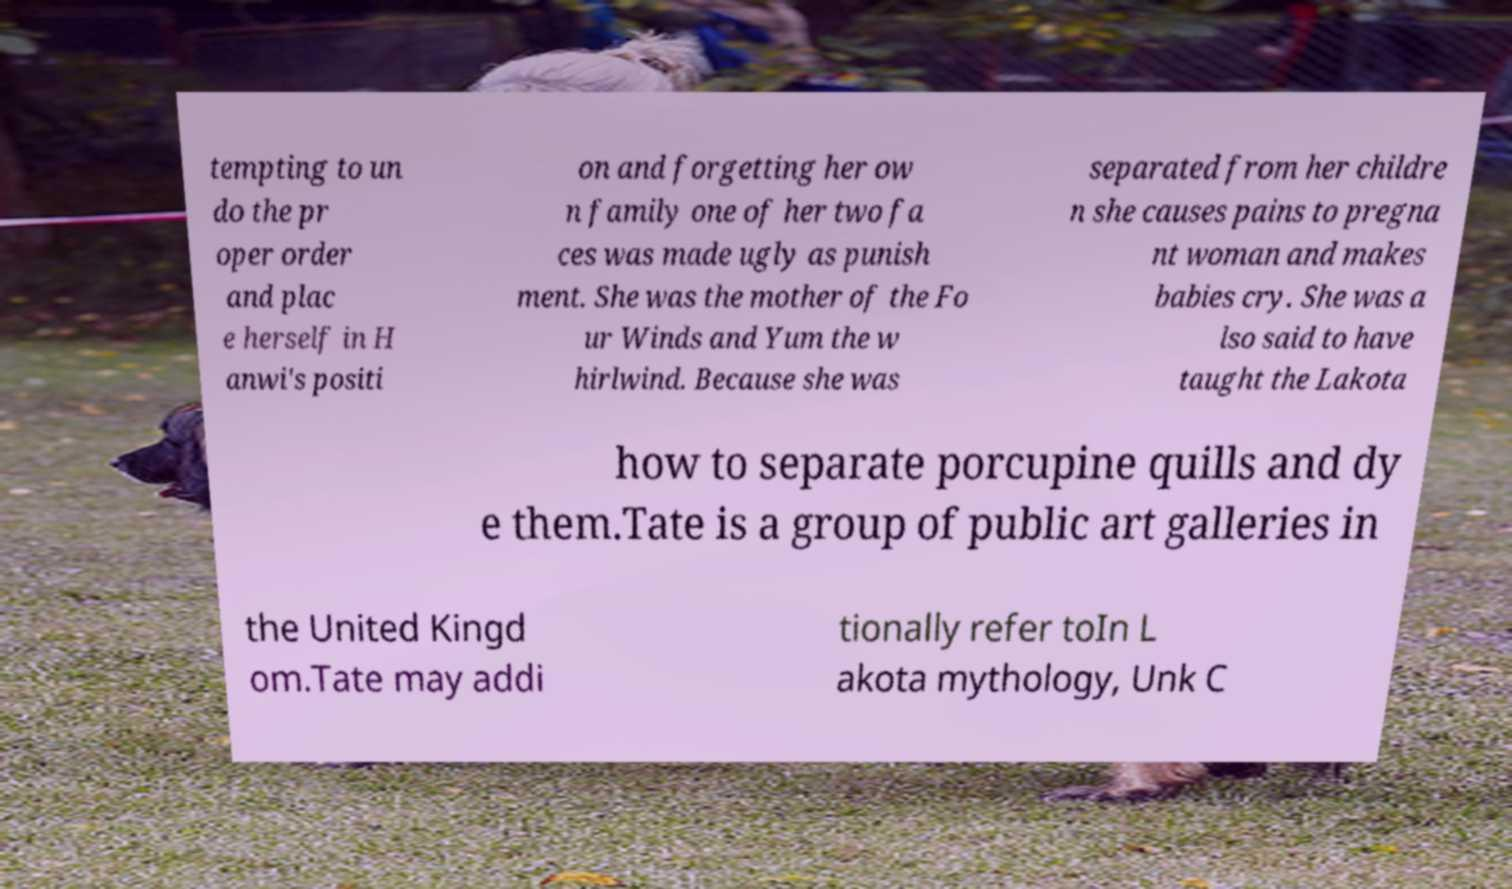There's text embedded in this image that I need extracted. Can you transcribe it verbatim? tempting to un do the pr oper order and plac e herself in H anwi's positi on and forgetting her ow n family one of her two fa ces was made ugly as punish ment. She was the mother of the Fo ur Winds and Yum the w hirlwind. Because she was separated from her childre n she causes pains to pregna nt woman and makes babies cry. She was a lso said to have taught the Lakota how to separate porcupine quills and dy e them.Tate is a group of public art galleries in the United Kingd om.Tate may addi tionally refer toIn L akota mythology, Unk C 